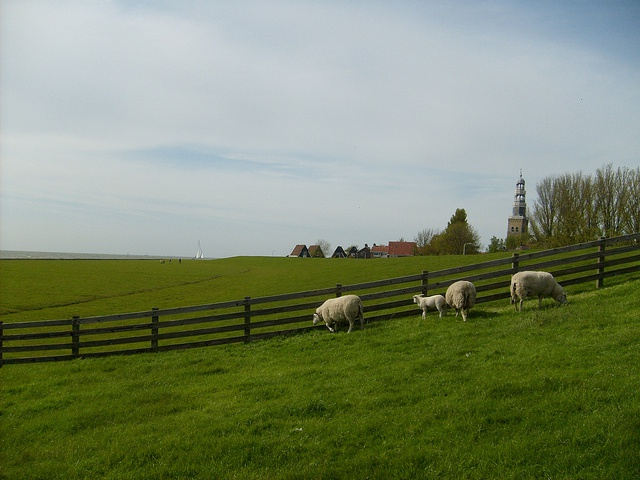Describe the objects in this image and their specific colors. I can see sheep in lightgray, black, darkgreen, tan, and gray tones, sheep in lightgray, black, tan, darkgreen, and gray tones, sheep in lightgray, black, tan, darkgreen, and gray tones, sheep in lightgray, black, gray, darkgreen, and tan tones, and boat in lightgray, darkgray, and gray tones in this image. 